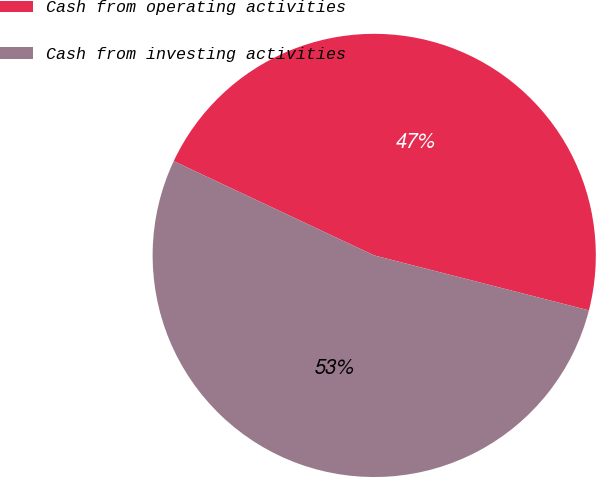Convert chart to OTSL. <chart><loc_0><loc_0><loc_500><loc_500><pie_chart><fcel>Cash from operating activities<fcel>Cash from investing activities<nl><fcel>46.99%<fcel>53.01%<nl></chart> 